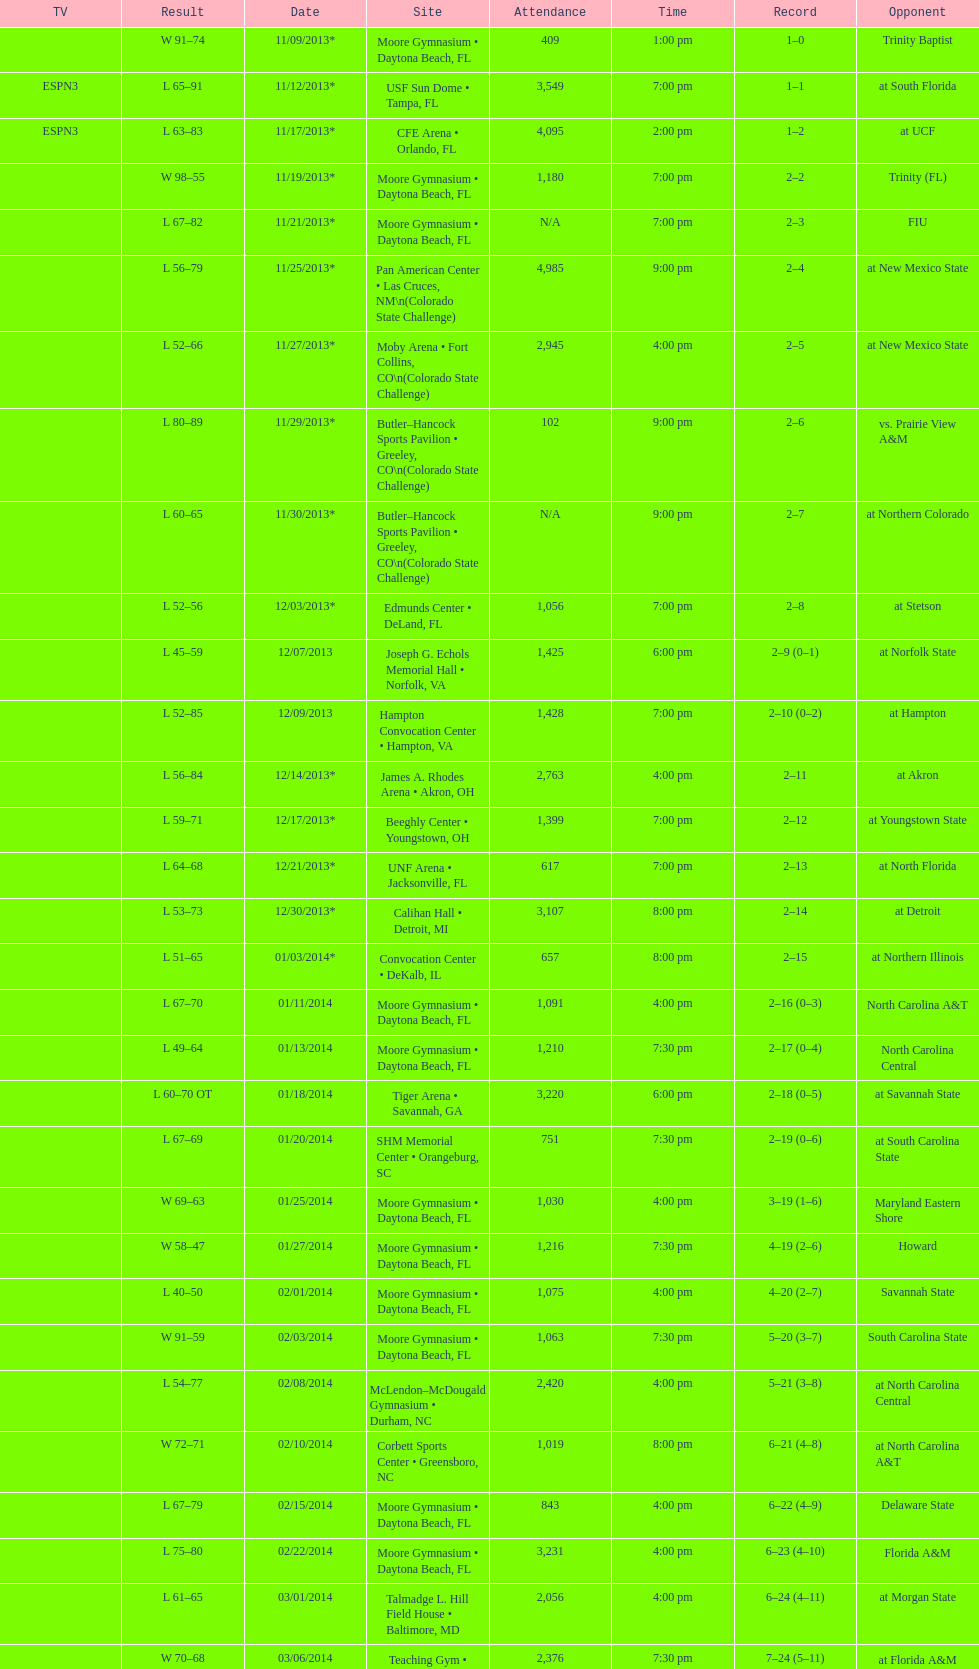How many teams had at most an attendance of 1,000? 6. 